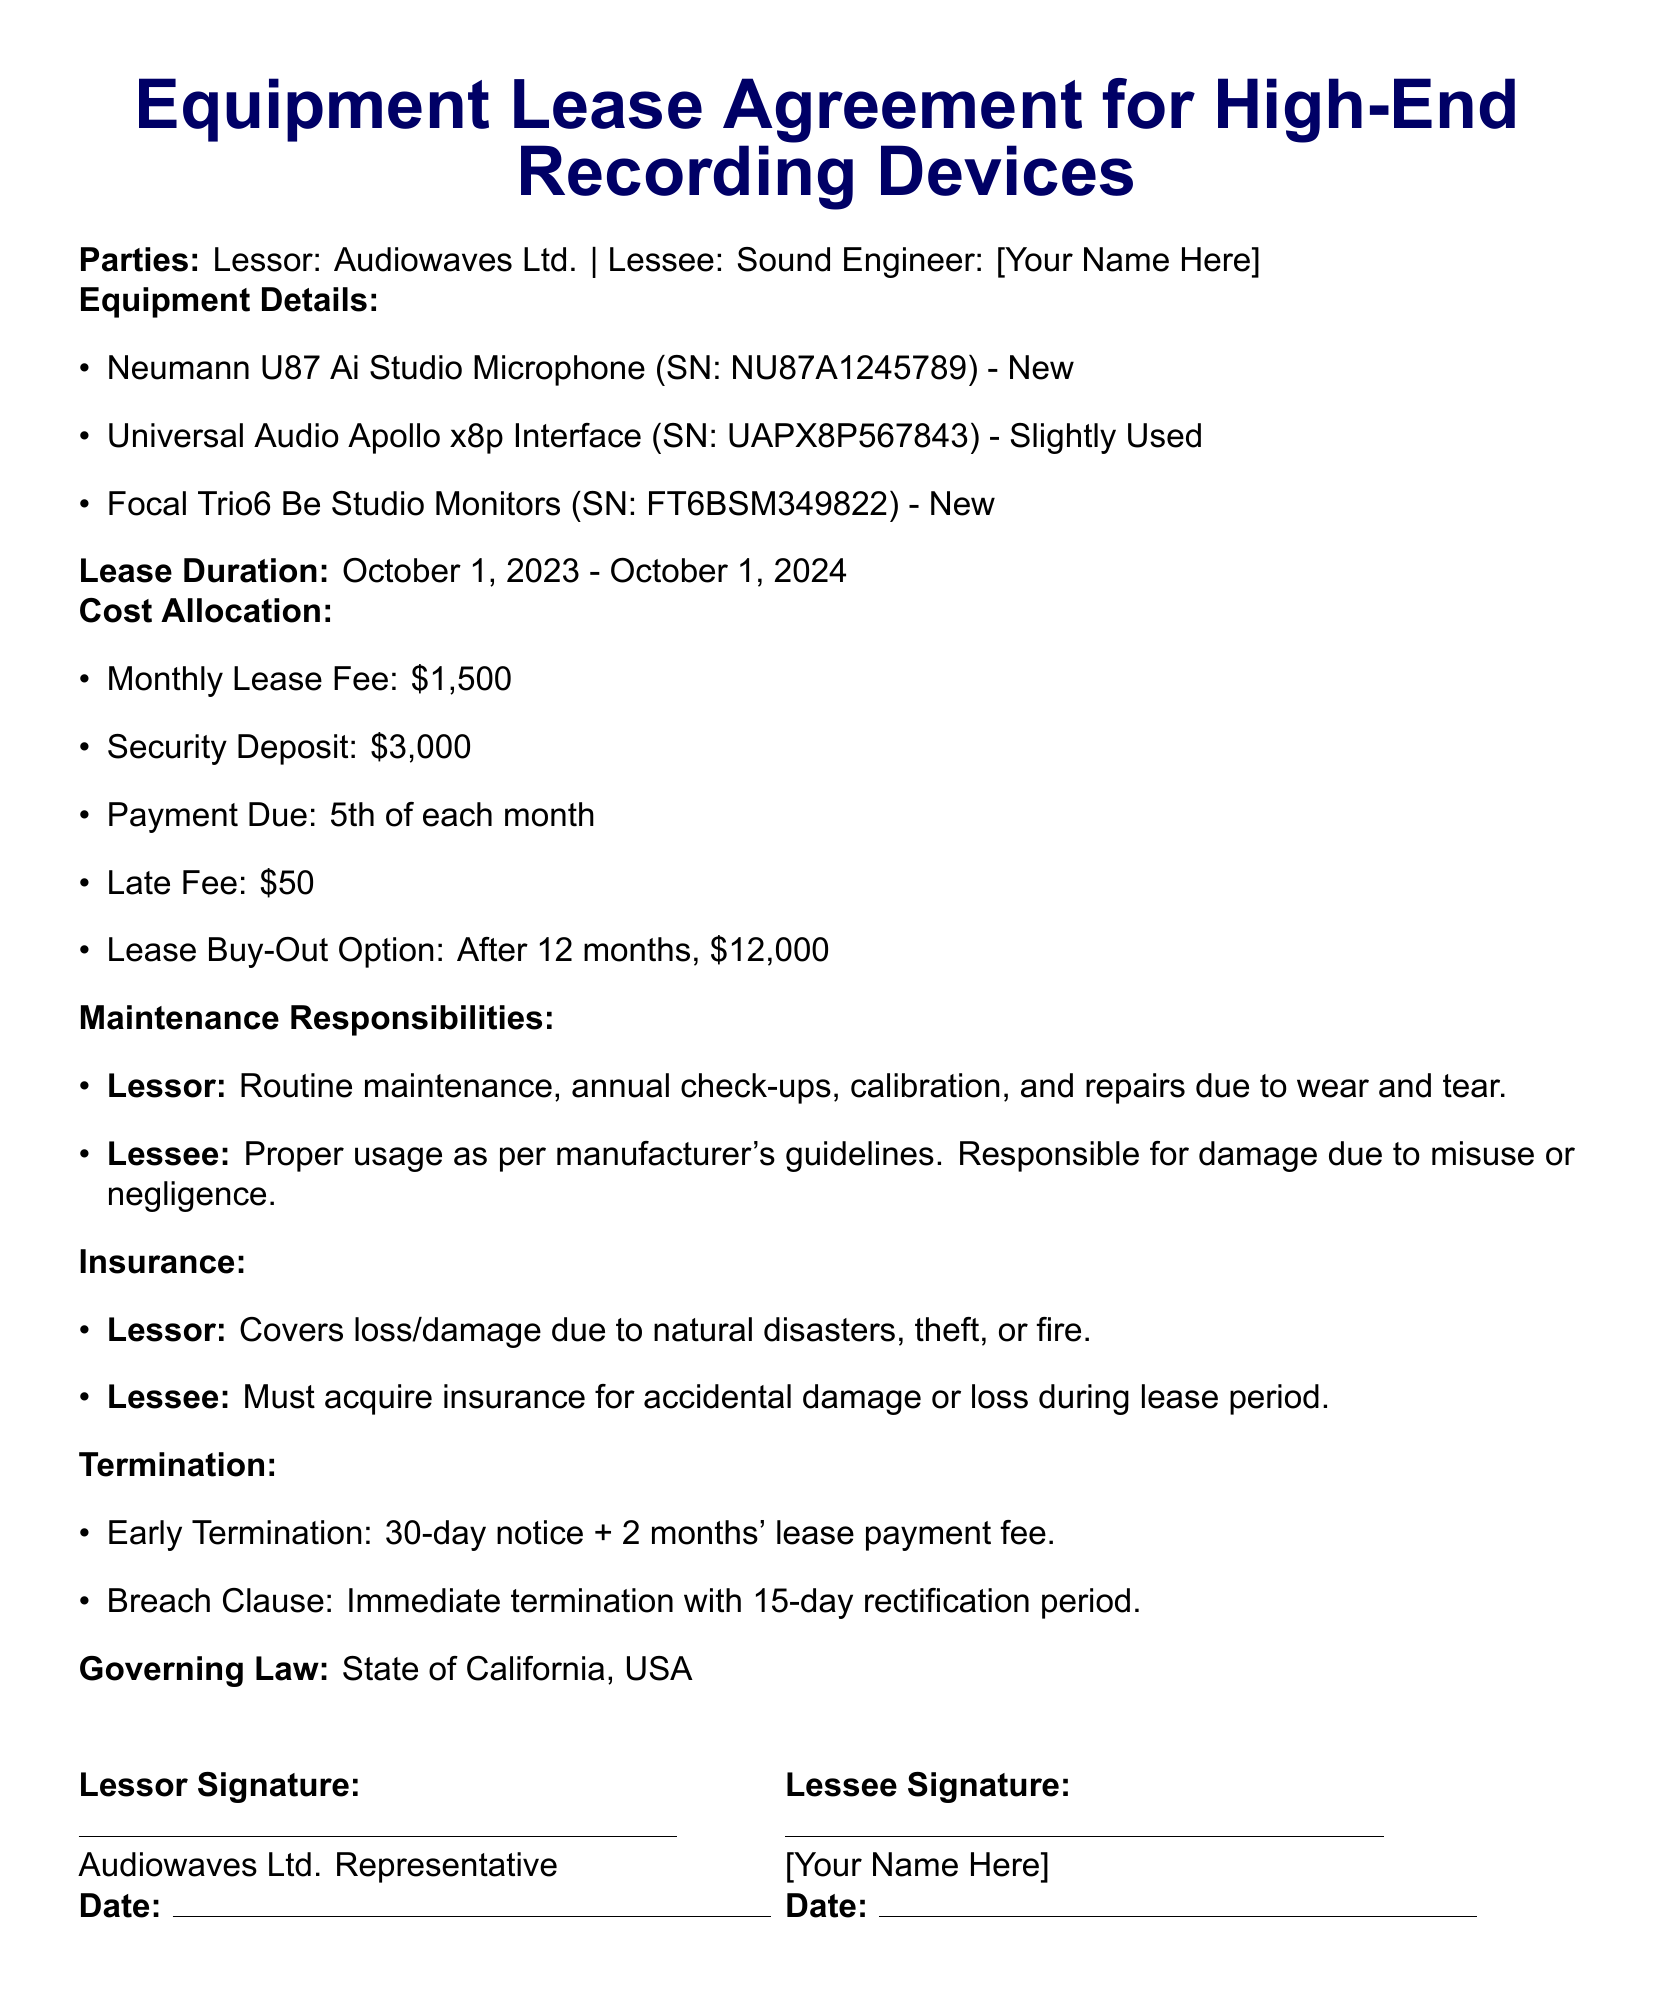What is the lease duration? The lease duration is specified in the document as the period from October 1, 2023, to October 1, 2024.
Answer: October 1, 2023 - October 1, 2024 What is the monthly lease fee? The monthly lease fee is directly stated in the cost allocation section of the document.
Answer: $1,500 Who is responsible for routine maintenance? The maintenance responsibilities section clearly states who is in charge of various maintenance tasks.
Answer: Lessor How much is the security deposit? The amount for the security deposit is mentioned in the cost allocation section.
Answer: $3,000 What must the lessee acquire during the lease period? The insurance section indicates the responsibility of the lessee in terms of insurance acquisition.
Answer: Insurance for accidental damage or loss How much is the late fee? The late fee amount is specified in the document under cost allocation.
Answer: $50 What is the breach clause termination period? The document outlines the specifics regarding the breach clause, including the rectification period.
Answer: 15-day What is the lease buy-out option price? The lease buy-out option is clearly stated in the cost allocation section.
Answer: $12,000 